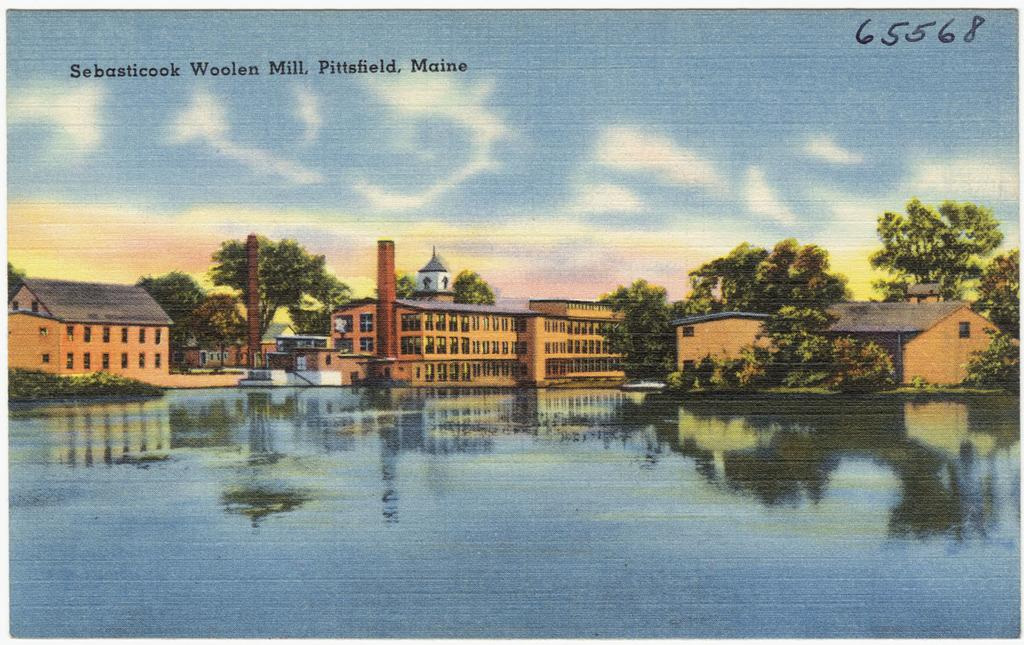What is the main subject in the center of the image? There is a poster in the center of the image. What is depicted on the poster? The poster contains trees and buildings. What can be seen at the bottom side of the image? There is water at the bottom side of the image. How many bricks are used to build the debt in the image? There is no mention of bricks or debt in the image; it features a poster with trees and buildings, and water at the bottom. 